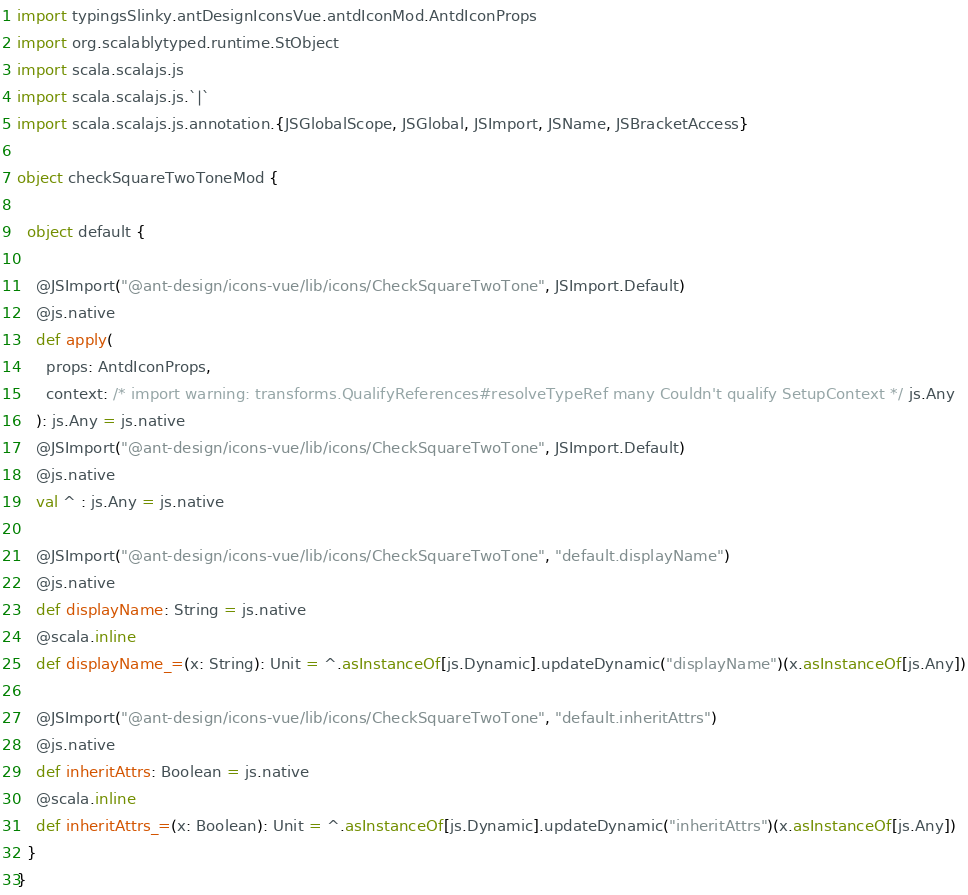<code> <loc_0><loc_0><loc_500><loc_500><_Scala_>
import typingsSlinky.antDesignIconsVue.antdIconMod.AntdIconProps
import org.scalablytyped.runtime.StObject
import scala.scalajs.js
import scala.scalajs.js.`|`
import scala.scalajs.js.annotation.{JSGlobalScope, JSGlobal, JSImport, JSName, JSBracketAccess}

object checkSquareTwoToneMod {
  
  object default {
    
    @JSImport("@ant-design/icons-vue/lib/icons/CheckSquareTwoTone", JSImport.Default)
    @js.native
    def apply(
      props: AntdIconProps,
      context: /* import warning: transforms.QualifyReferences#resolveTypeRef many Couldn't qualify SetupContext */ js.Any
    ): js.Any = js.native
    @JSImport("@ant-design/icons-vue/lib/icons/CheckSquareTwoTone", JSImport.Default)
    @js.native
    val ^ : js.Any = js.native
    
    @JSImport("@ant-design/icons-vue/lib/icons/CheckSquareTwoTone", "default.displayName")
    @js.native
    def displayName: String = js.native
    @scala.inline
    def displayName_=(x: String): Unit = ^.asInstanceOf[js.Dynamic].updateDynamic("displayName")(x.asInstanceOf[js.Any])
    
    @JSImport("@ant-design/icons-vue/lib/icons/CheckSquareTwoTone", "default.inheritAttrs")
    @js.native
    def inheritAttrs: Boolean = js.native
    @scala.inline
    def inheritAttrs_=(x: Boolean): Unit = ^.asInstanceOf[js.Dynamic].updateDynamic("inheritAttrs")(x.asInstanceOf[js.Any])
  }
}
</code> 